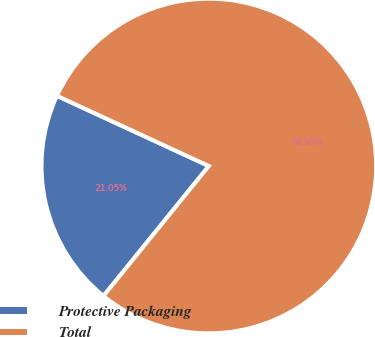Convert chart to OTSL. <chart><loc_0><loc_0><loc_500><loc_500><pie_chart><fcel>Protective Packaging<fcel>Total<nl><fcel>21.05%<fcel>78.95%<nl></chart> 